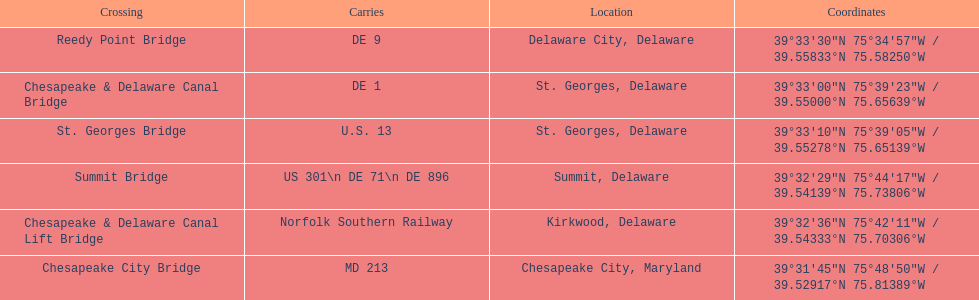Which bridge has their location in summit, delaware? Summit Bridge. 